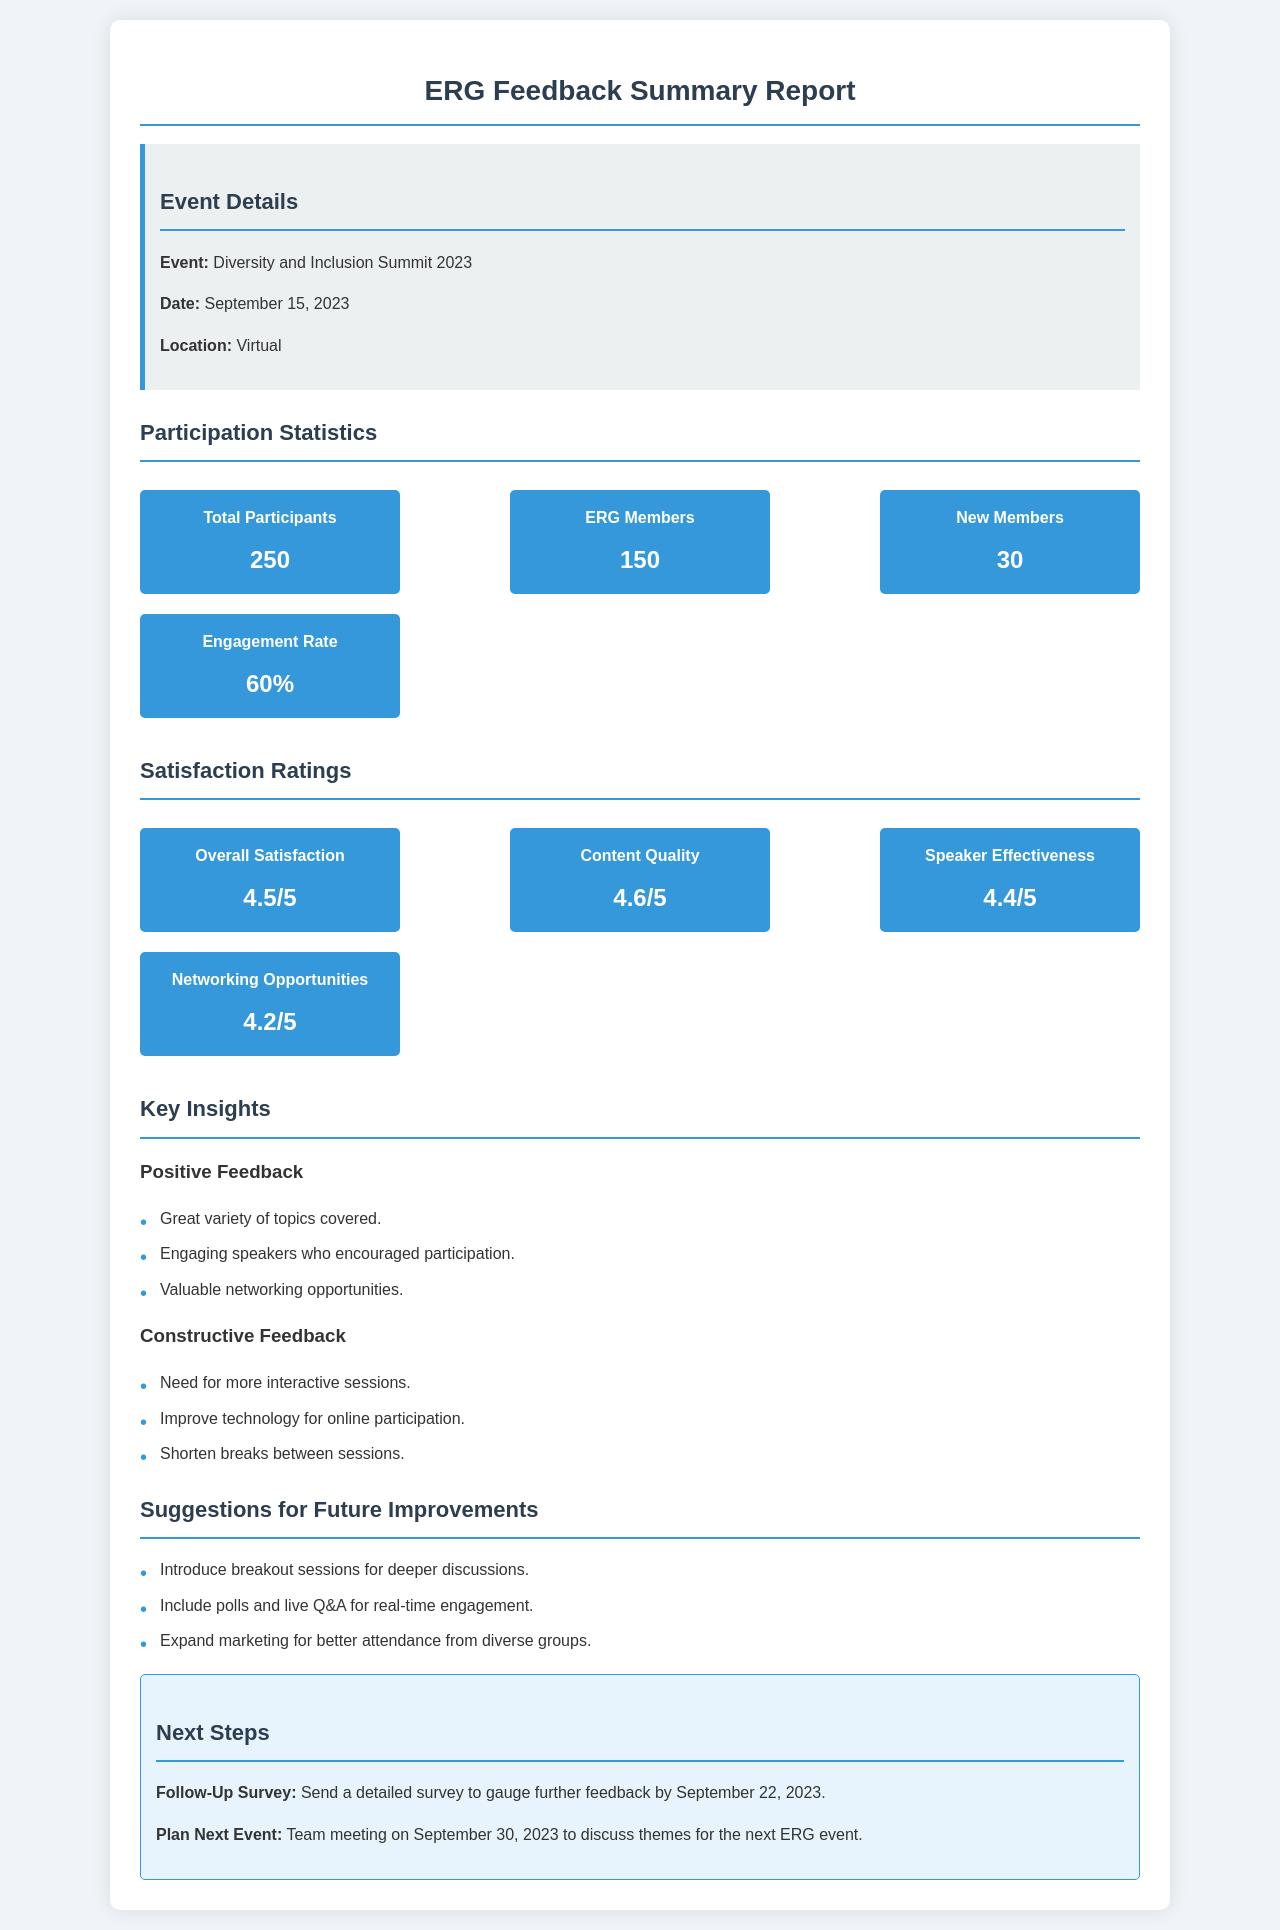What is the event name? The event name is mentioned in the document as "Diversity and Inclusion Summit 2023."
Answer: Diversity and Inclusion Summit 2023 What is the date of the event? The date of the event is specified in the document as September 15, 2023.
Answer: September 15, 2023 How many total participants were there? The total number of participants is stated as 250 in the participation statistics section.
Answer: 250 What was the overall satisfaction rating? The overall satisfaction rating is provided in the satisfaction ratings section and is 4.5.
Answer: 4.5 What percentage was the engagement rate? The engagement rate is indicated in the participation statistics section as 60%.
Answer: 60% What is one area of constructive feedback? The document lists areas of constructive feedback; one example is the need for more interactive sessions.
Answer: Need for more interactive sessions What is one suggestion for future improvements? A suggestion listed for future improvements is introducing breakout sessions for deeper discussions.
Answer: Introduce breakout sessions for deeper discussions What date is the follow-up survey planned to be sent by? The follow-up survey is mentioned to be sent by September 22, 2023.
Answer: September 22, 2023 When is the team meeting scheduled to plan the next event? The team meeting to discuss themes for the next ERG event is scheduled for September 30, 2023.
Answer: September 30, 2023 